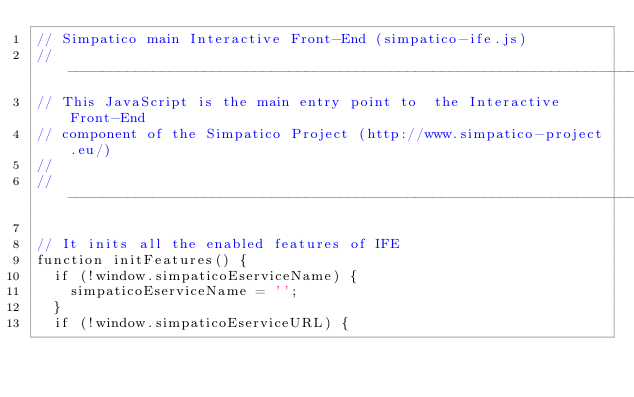Convert code to text. <code><loc_0><loc_0><loc_500><loc_500><_JavaScript_>// Simpatico main Interactive Front-End (simpatico-ife.js)
//-----------------------------------------------------------------------------
// This JavaScript is the main entry point to  the Interactive Front-End
// component of the Simpatico Project (http://www.simpatico-project.eu/)
//
//-----------------------------------------------------------------------------

// It inits all the enabled features of IFE
function initFeatures() {
  if (!window.simpaticoEserviceName) {
    simpaticoEserviceName = '';
  }
  if (!window.simpaticoEserviceURL) {</code> 